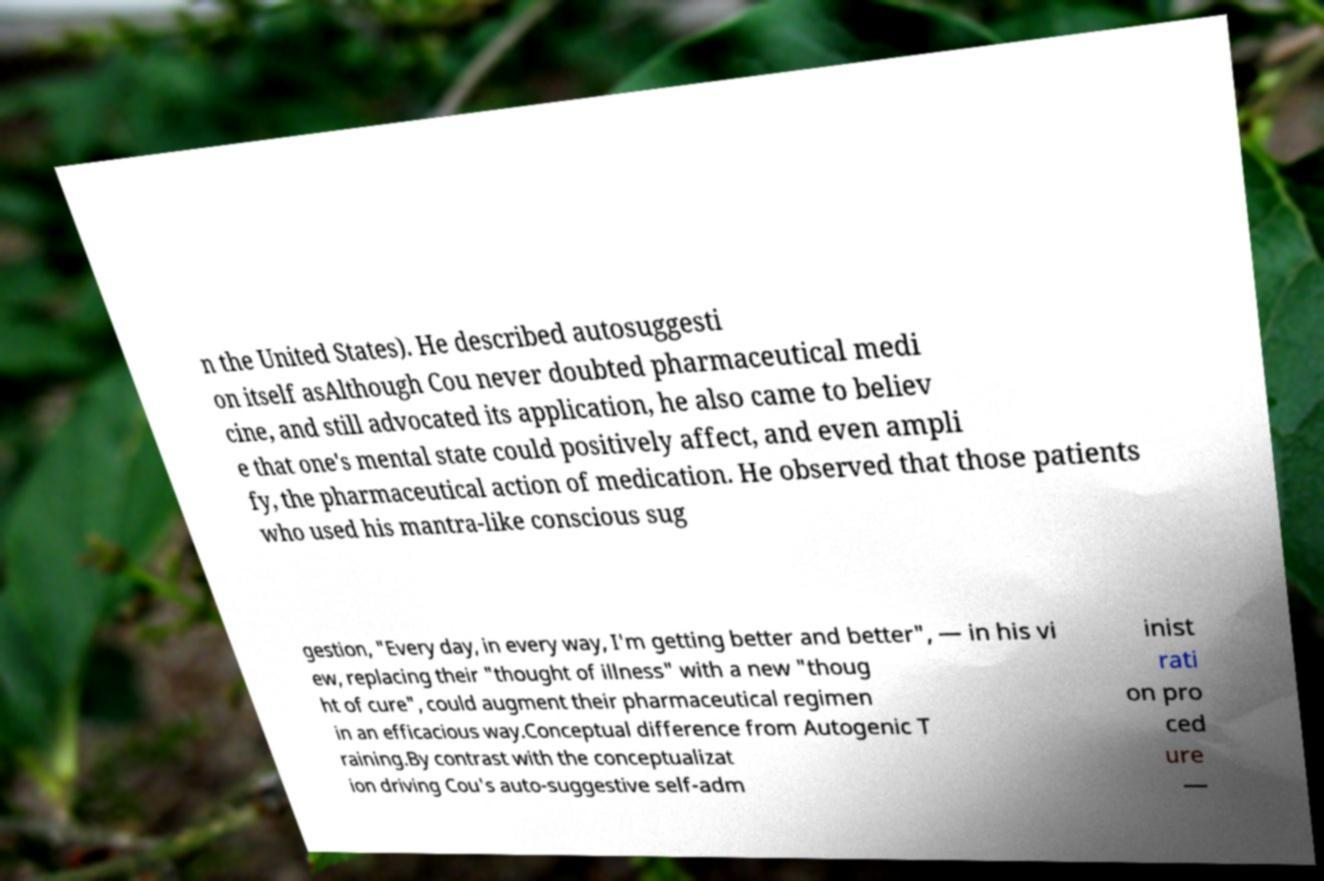Please read and relay the text visible in this image. What does it say? n the United States). He described autosuggesti on itself asAlthough Cou never doubted pharmaceutical medi cine, and still advocated its application, he also came to believ e that one's mental state could positively affect, and even ampli fy, the pharmaceutical action of medication. He observed that those patients who used his mantra-like conscious sug gestion, "Every day, in every way, I'm getting better and better", — in his vi ew, replacing their "thought of illness" with a new "thoug ht of cure", could augment their pharmaceutical regimen in an efficacious way.Conceptual difference from Autogenic T raining.By contrast with the conceptualizat ion driving Cou's auto-suggestive self-adm inist rati on pro ced ure — 